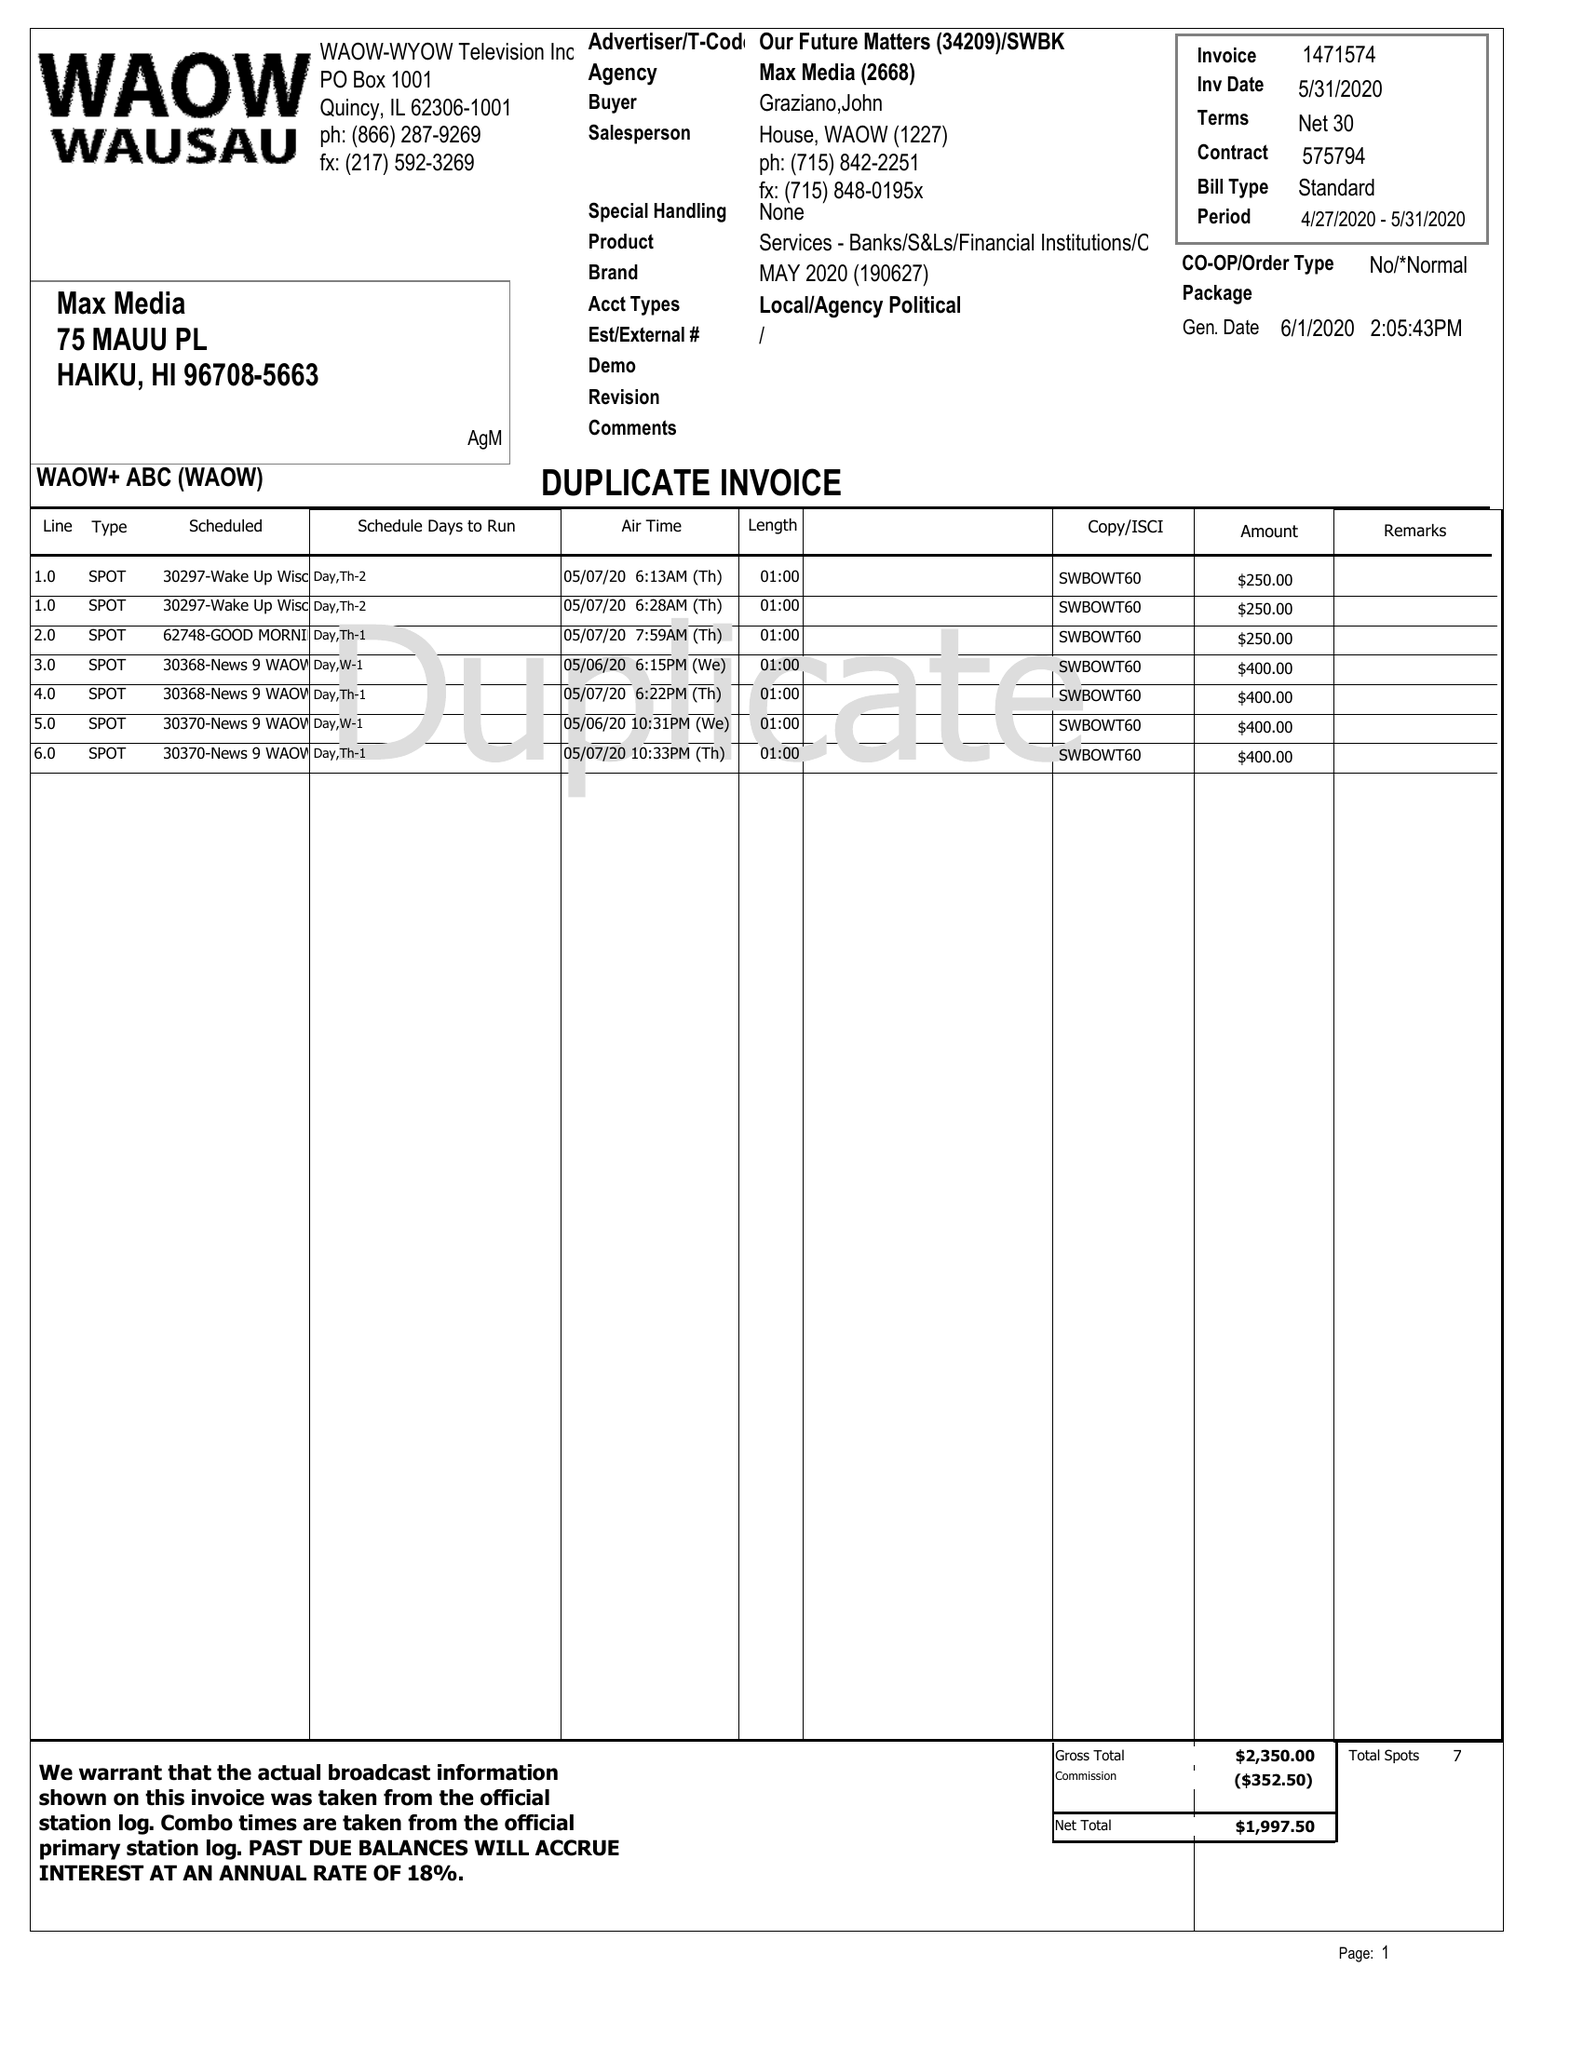What is the value for the contract_num?
Answer the question using a single word or phrase. 1471574 